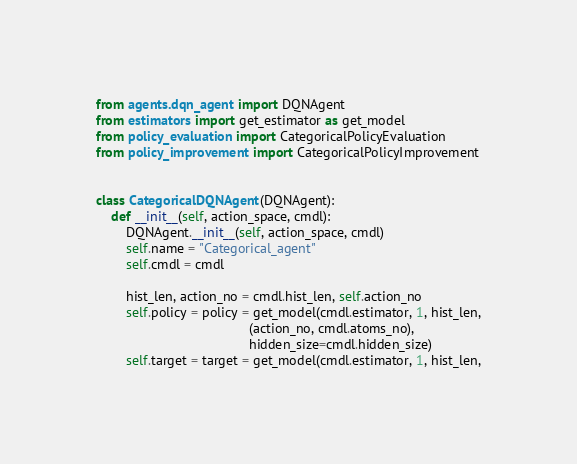<code> <loc_0><loc_0><loc_500><loc_500><_Python_>from agents.dqn_agent import DQNAgent
from estimators import get_estimator as get_model
from policy_evaluation import CategoricalPolicyEvaluation
from policy_improvement import CategoricalPolicyImprovement


class CategoricalDQNAgent(DQNAgent):
    def __init__(self, action_space, cmdl):
        DQNAgent.__init__(self, action_space, cmdl)
        self.name = "Categorical_agent"
        self.cmdl = cmdl

        hist_len, action_no = cmdl.hist_len, self.action_no
        self.policy = policy = get_model(cmdl.estimator, 1, hist_len,
                                         (action_no, cmdl.atoms_no),
                                         hidden_size=cmdl.hidden_size)
        self.target = target = get_model(cmdl.estimator, 1, hist_len,</code> 